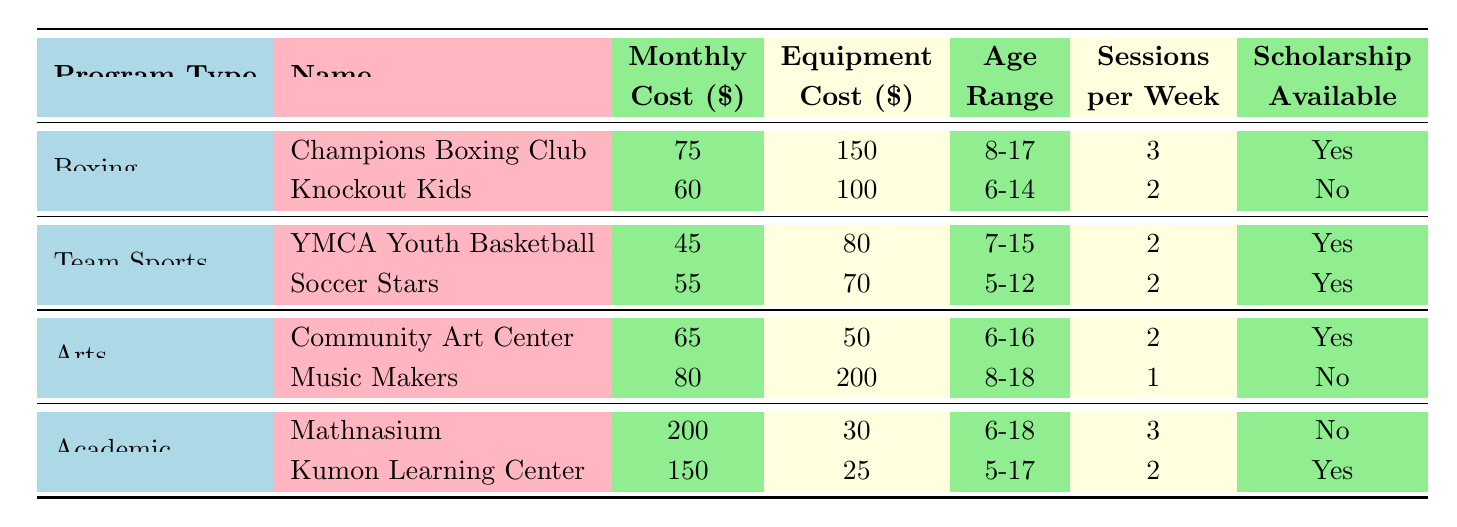What is the monthly cost of the Champions Boxing Club? The table shows that the monthly cost for the Champions Boxing Club is listed under the 'Monthly Cost' column next to its name. The value is 75.
Answer: 75 Which program has the highest equipment cost? By examining the 'Equipment Cost' column, the program with the highest cost is the Music Makers, which has an equipment cost of 200.
Answer: Music Makers Are there scholarships available for the Knockout Kids program? The table indicates "No" under the 'Scholarship Available' column for the Knockout Kids program, meaning there are no scholarships.
Answer: No What is the total monthly cost for both boxing programs? The total monthly cost is calculated by adding the monthly costs of both boxing programs: 75 (Champions Boxing Club) + 60 (Knockout Kids) = 135.
Answer: 135 How many sessions are offered per week in the Arts programs? The Arts programs offer a total of 2 sessions per week for Community Art Center and 1 session for Music Makers. Adding these gives: 2 + 1 = 3 sessions weekly.
Answer: 3 Which program has the widest age range? The age range for Mathnasium is 6-18, which is wider than any other program listed. To confirm, we check the ranges for each program.
Answer: Mathnasium If a family can only afford $100 per month, which boxing program can they enroll their child in? The family can afford $100 and the Knockout Kids program has a monthly cost of 60, which is within this budget. The Champions Boxing Club costs 75 and is also an option. Both can be enrolled in based on budget.
Answer: Knockout Kids Is the YMCA Youth Basketball program available for children aged 16? The age range for YMCA Youth Basketball is 7-15, so it does not accommodate 16-year-olds.
Answer: No What is the average monthly cost of all the programs listed? To calculate the average, sum the monthly costs: 75 + 60 + 45 + 55 + 65 + 80 + 200 + 150 = 730, and then divide by the number of programs (8): 730 / 8 = 91.25.
Answer: 91.25 Which after-school program types offer scholarships? By checking the 'Scholarship Available' column for each program type, we find that Boxing, Team Sports, and Arts offer scholarships since they have "Yes" listed. The Academic program only has Kumon Learning Center that offers a scholarship.
Answer: Boxing, Team Sports, Arts 